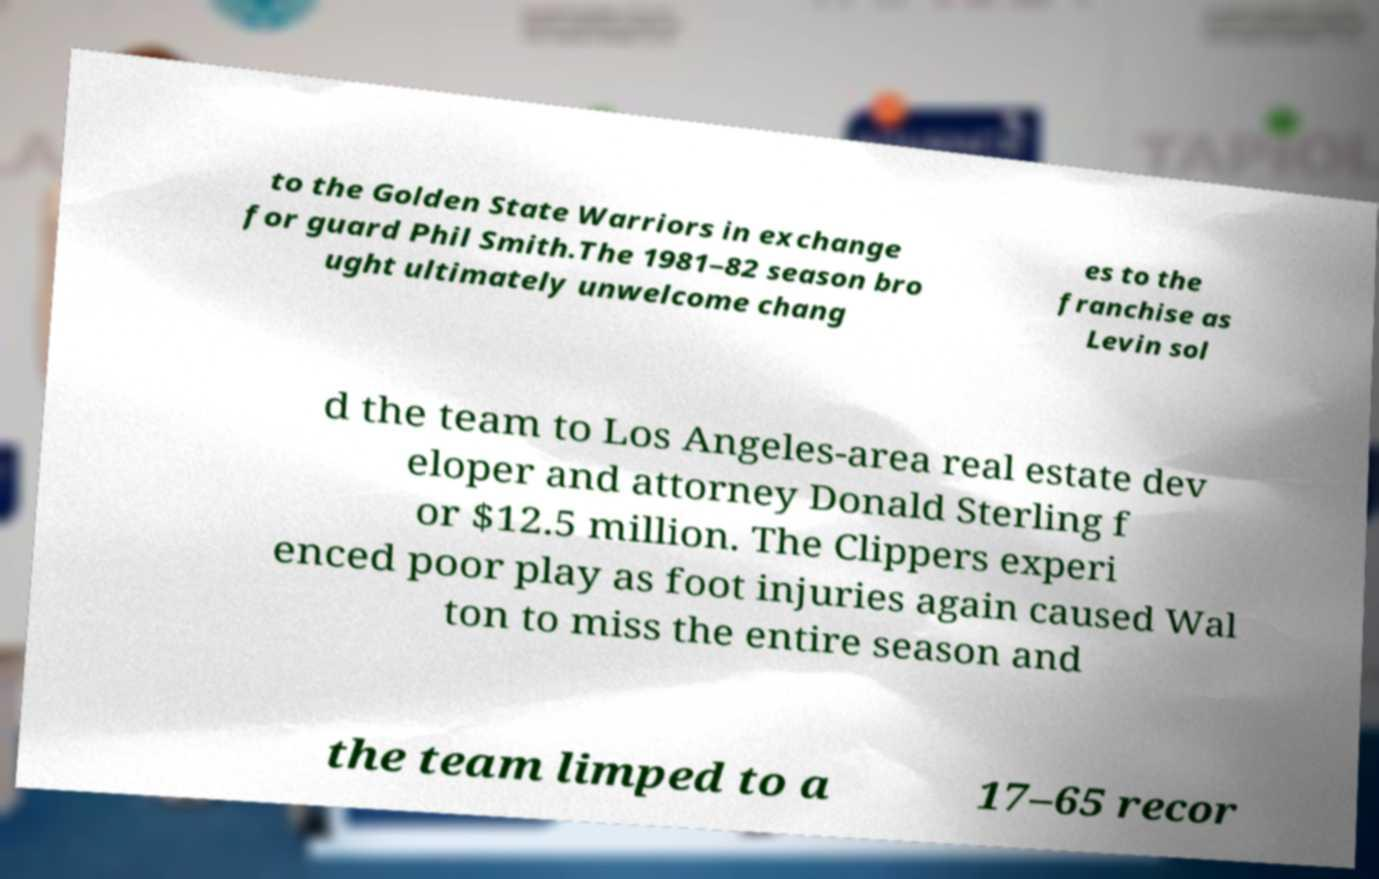What messages or text are displayed in this image? I need them in a readable, typed format. to the Golden State Warriors in exchange for guard Phil Smith.The 1981–82 season bro ught ultimately unwelcome chang es to the franchise as Levin sol d the team to Los Angeles-area real estate dev eloper and attorney Donald Sterling f or $12.5 million. The Clippers experi enced poor play as foot injuries again caused Wal ton to miss the entire season and the team limped to a 17–65 recor 